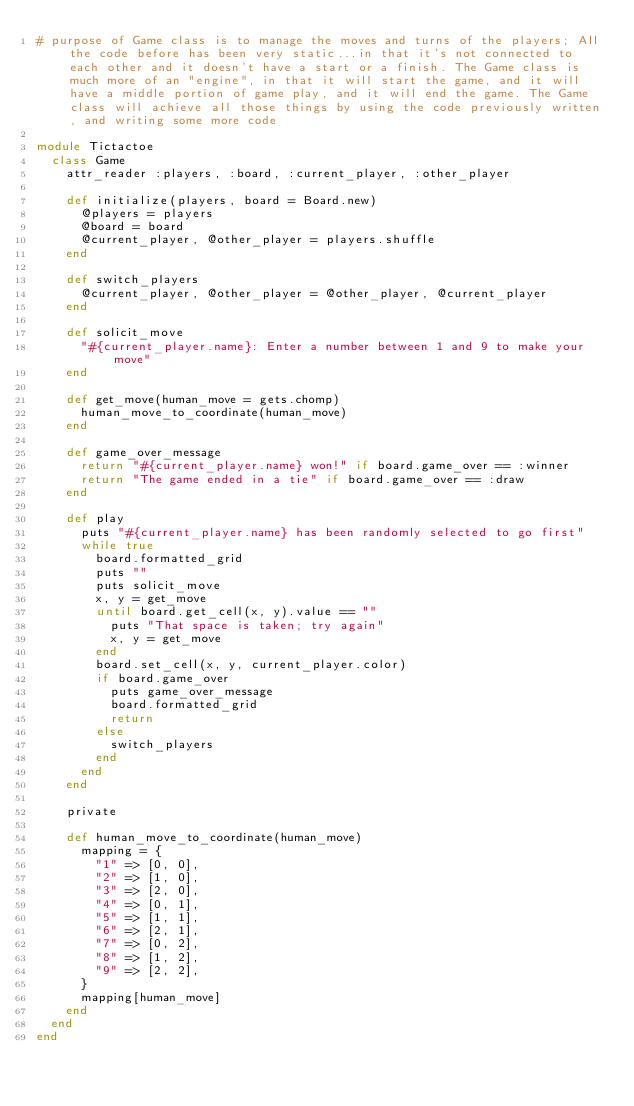Convert code to text. <code><loc_0><loc_0><loc_500><loc_500><_Ruby_># purpose of Game class is to manage the moves and turns of the players; All the code before has been very static...in that it's not connected to each other and it doesn't have a start or a finish. The Game class is much more of an "engine", in that it will start the game, and it will have a middle portion of game play, and it will end the game. The Game class will achieve all those things by using the code previously written, and writing some more code

module Tictactoe
  class Game
    attr_reader :players, :board, :current_player, :other_player

    def initialize(players, board = Board.new)
      @players = players
      @board = board
      @current_player, @other_player = players.shuffle
    end

    def switch_players
      @current_player, @other_player = @other_player, @current_player
    end

    def solicit_move
      "#{current_player.name}: Enter a number between 1 and 9 to make your move"
    end

    def get_move(human_move = gets.chomp)
      human_move_to_coordinate(human_move)
    end

    def game_over_message
      return "#{current_player.name} won!" if board.game_over == :winner
      return "The game ended in a tie" if board.game_over == :draw
    end

    def play
      puts "#{current_player.name} has been randomly selected to go first"
      while true
        board.formatted_grid
        puts ""
        puts solicit_move
        x, y = get_move
        until board.get_cell(x, y).value == ""
          puts "That space is taken; try again"
          x, y = get_move
        end
        board.set_cell(x, y, current_player.color)
        if board.game_over
          puts game_over_message
          board.formatted_grid
          return
        else
          switch_players
        end
      end
    end

    private

    def human_move_to_coordinate(human_move)
      mapping = {
        "1" => [0, 0],
        "2" => [1, 0],
        "3" => [2, 0],
        "4" => [0, 1],
        "5" => [1, 1],
        "6" => [2, 1],
        "7" => [0, 2],
        "8" => [1, 2],
        "9" => [2, 2],
      }
      mapping[human_move]
    end
  end
end
</code> 